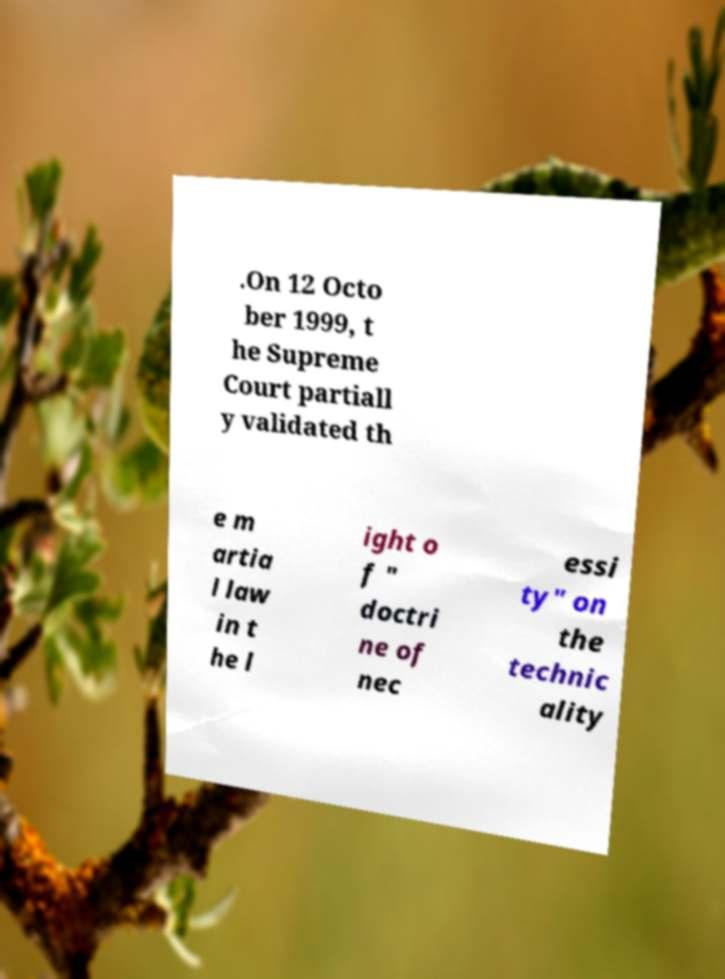Could you extract and type out the text from this image? .On 12 Octo ber 1999, t he Supreme Court partiall y validated th e m artia l law in t he l ight o f " doctri ne of nec essi ty" on the technic ality 